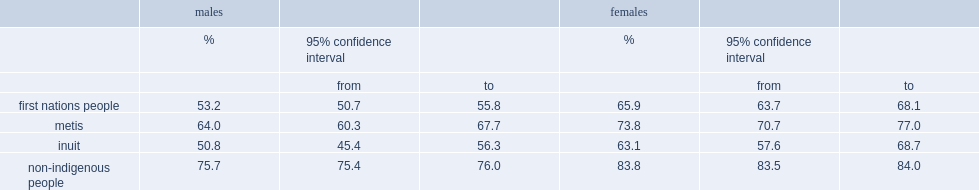Which group had the lower probability of living to age 75, the first nations people or the non-indigenous people in 2011? First nations people. Which group had the lower probability of living to age 75, the metis or the non-indigenous people in 2011? Metis. Which group had the lower probability of living to age 75, the inuit or the non-indigenous people in 2011? Inuit. Among the first nations household population, what was the percentage of the probability of living to age 75 for males in 2011? 53.2. Among the first nations household population, what was the percentage of the probability of living to age 75 for females in 2011? 65.9. How many percentage points was the probability of living to age 75 for males among the first nations household population lower than that among the non-indigenous household population in 2011? 22.5. How many percentage points was the probability of living to age 75 for females among the first nations household population lower than that among the non-indigenous household population in 2011? 17.9. For metis, what was the percentage of the probability of living to age 75 for males in 2011? 64.0. For metis, what was the percentage of the probability of living to age 75 for females in 2011? 73.8. How many percentage points was the probability of living to age 75 for metis males lower than that for the non-indigenous males in 2011? 11.7. How many percentage points was the probability of living to age 75 for metis females lower than that for the non-indigenous females in 2011? 10. For inuit, what was the percentage of the probability of living to age 75 for males in 2011? 50.8. For inuit, what was the percentage of the probability of living to age 75 for females in 2011? 63.1. For inuit, how many percentage points was the probability of living to age 75 for males lower than that for the non-indigenous males in 2011? 24.9. For inuit, how many percentage points was the probability of living to age 75 for females lower than that for the non-indigenous females in 2011? 20.7. 